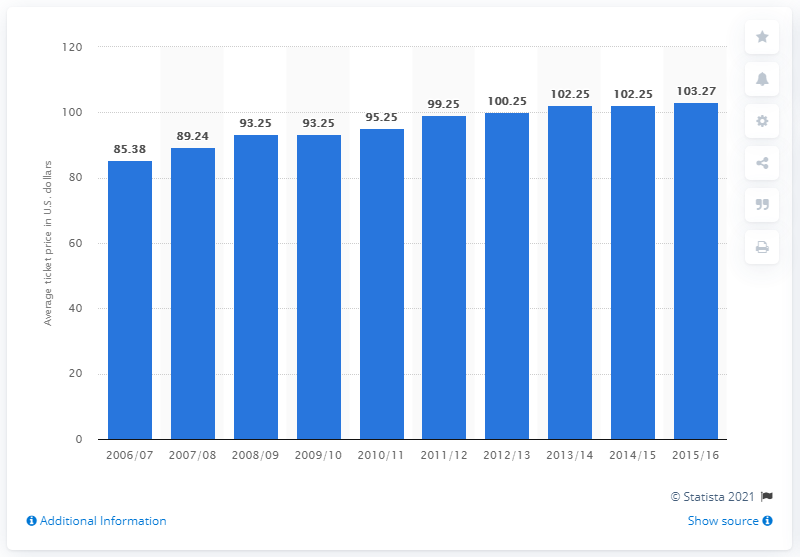Point out several critical features in this image. During the 2006/2007 season, the average ticket price was 85.38 dollars. 